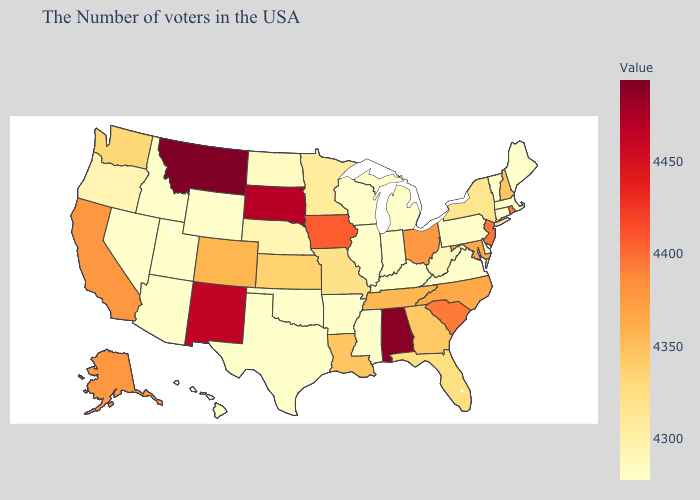Does California have the lowest value in the USA?
Short answer required. No. Which states have the lowest value in the Northeast?
Answer briefly. Maine, Massachusetts, Vermont, Connecticut, Pennsylvania. Does Mississippi have the lowest value in the South?
Be succinct. Yes. Does the map have missing data?
Be succinct. No. Does Texas have the highest value in the South?
Give a very brief answer. No. 